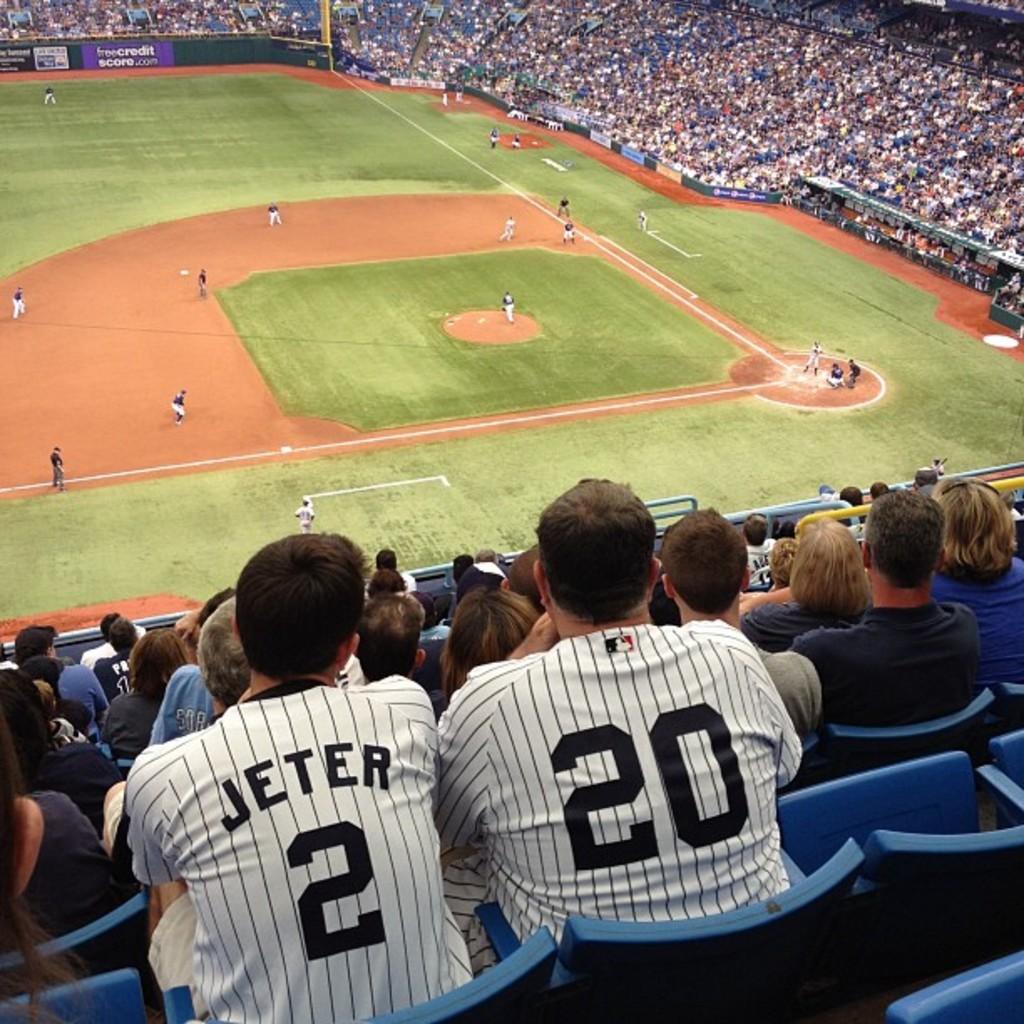Who is the man on the left's favorite baseball player?
Your response must be concise. Jeter. What number is the guy on the right?
Your answer should be very brief. 20. 